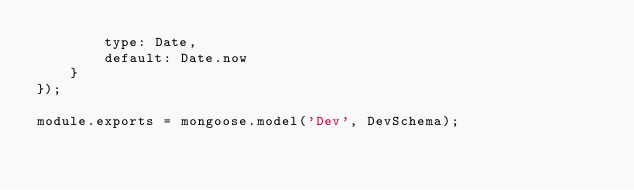<code> <loc_0><loc_0><loc_500><loc_500><_JavaScript_>		type: Date,
		default: Date.now
	}
});

module.exports = mongoose.model('Dev', DevSchema);
</code> 